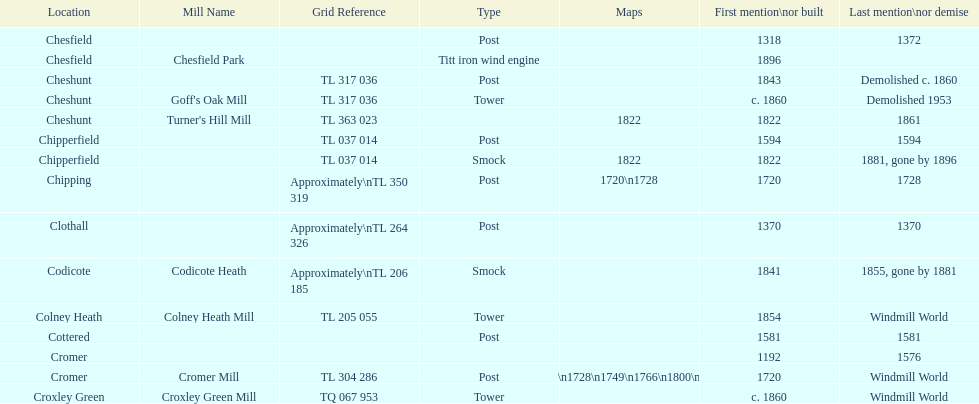What location has the most maps? Cromer. 